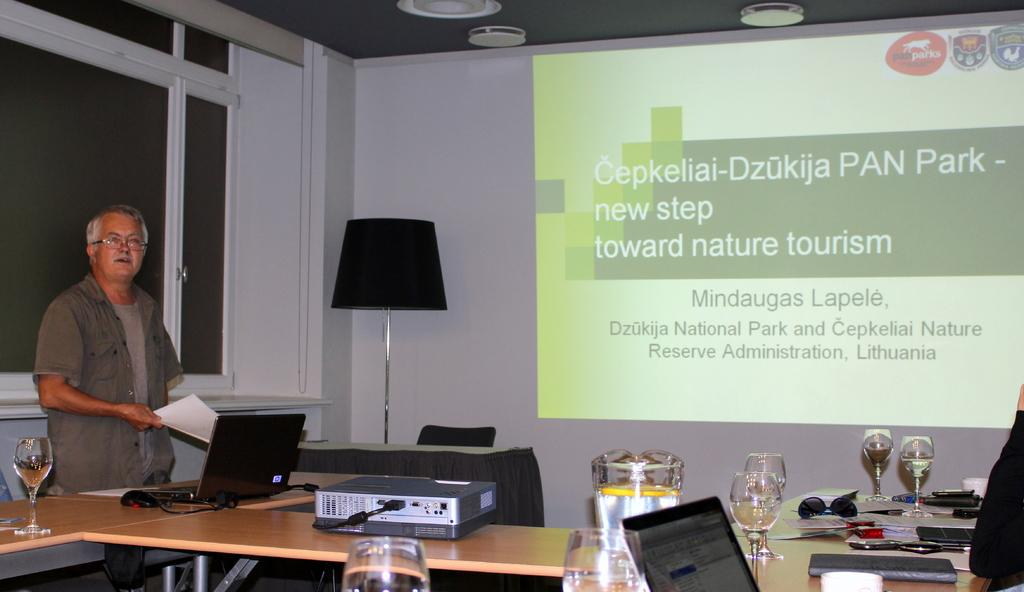Provide a one-sentence caption for the provided image. A man is standing next to a laptop that is projected onto a screen mentioning tourism. 